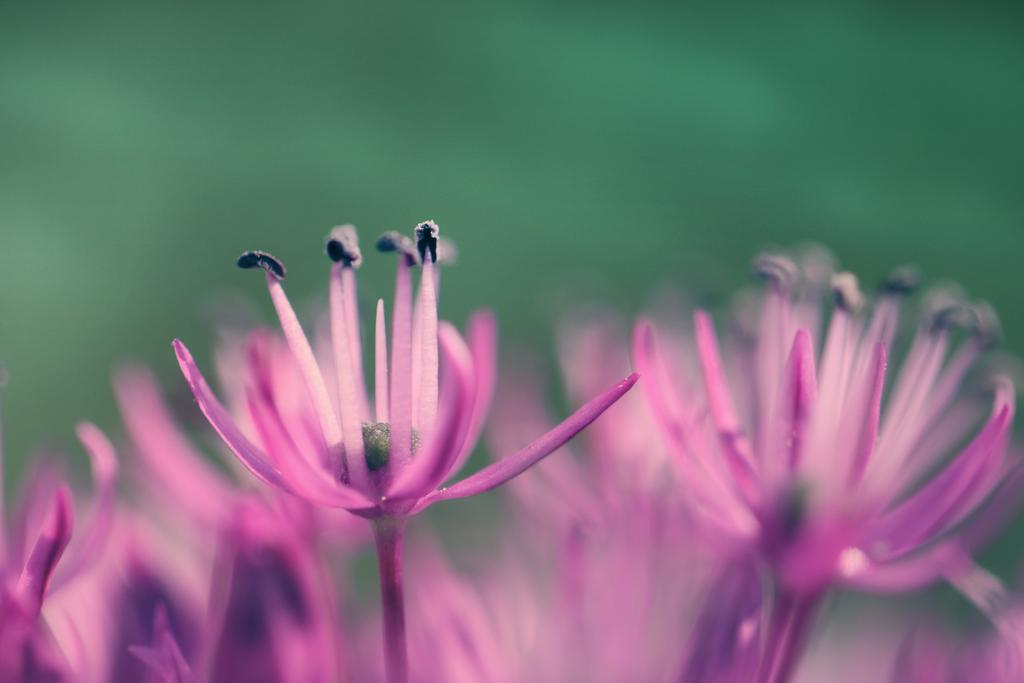What type of living organisms can be seen in the image? There are flowers in the image. What colors are the flowers in the image? The flowers are pink and black in color. What type of silver object can be seen interacting with the flowers in the image? There is no silver object present in the image; it only features flowers. 